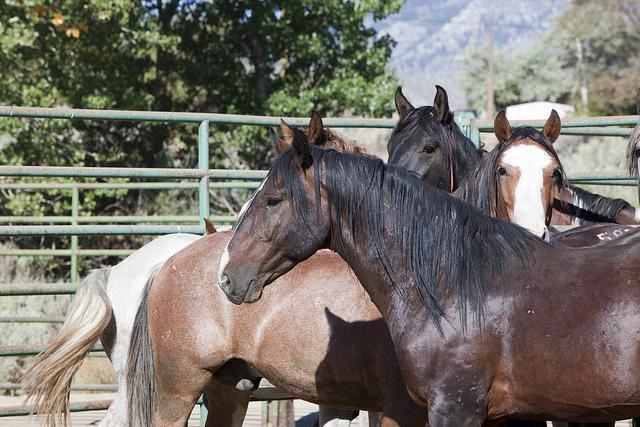How many of the horses have black manes?
Give a very brief answer. 3. How many horses are pictured?
Give a very brief answer. 3. How many horses are there?
Give a very brief answer. 4. 